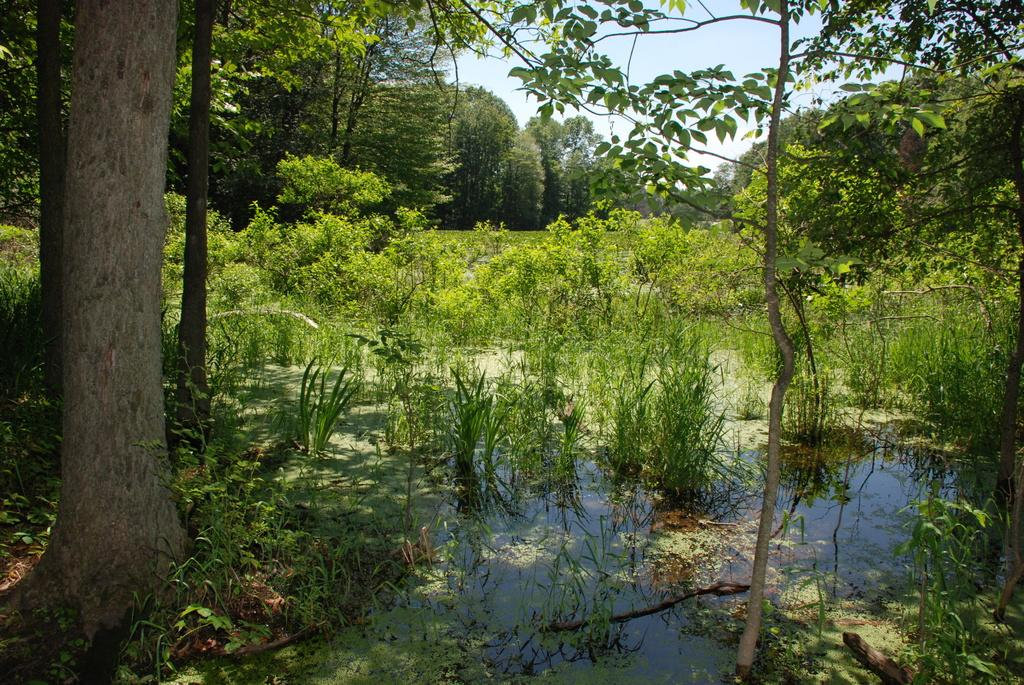What type of vegetation can be seen in the image? There is grass, trees, and plants in the image. What body of water is present in the image? There is a lake in the image. What is visible at the top of the image? The sky is visible at the top of the image. What color is the daughter's dress in the image? There is no daughter present in the image, so it is not possible to answer that question. 